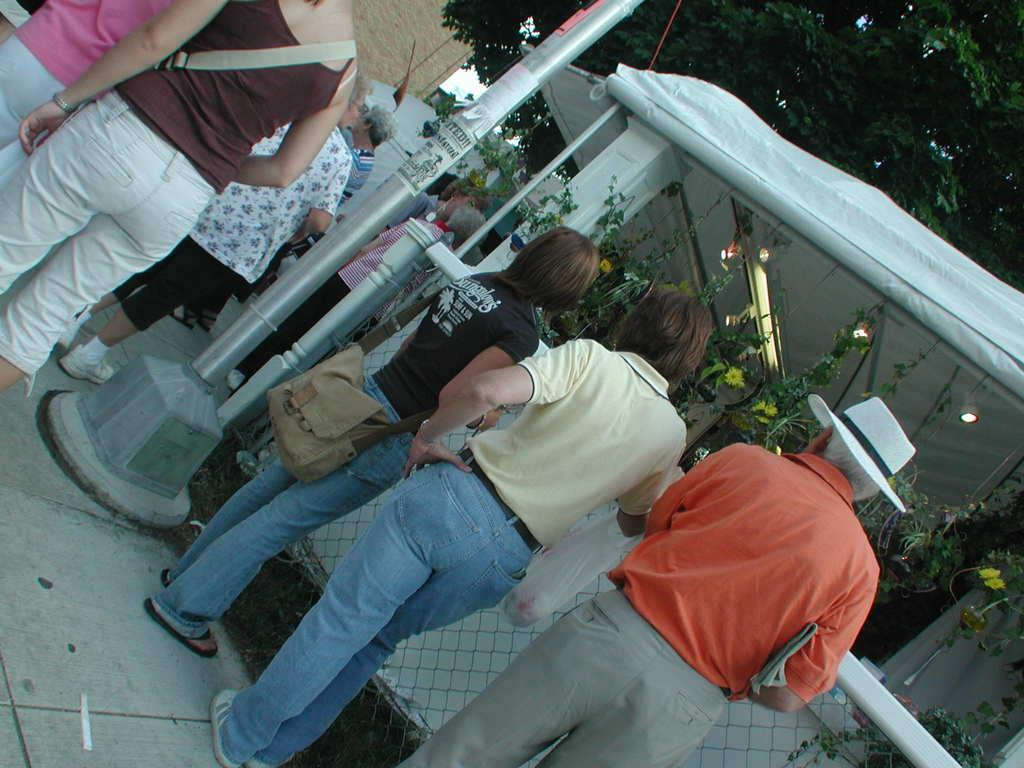What are the people in the image doing? The people in the image are standing on the road. What object can be seen in the image that is typically used for supporting signs or other items? There is a pole in the image. What object can be seen in the image that is typically used for catching or holding objects? There is a net in the image. What type of vegetation can be seen in the image? There are plants in the image. What type of lighting is present in the image? There are ceiling lights in the image. What type of structures can be seen in the image? There are buildings in the image. What type of vegetation can be seen in the background of the image? There are trees in the background of the image. What type of sweater can be seen in the image? There is no sweater present in the image. 